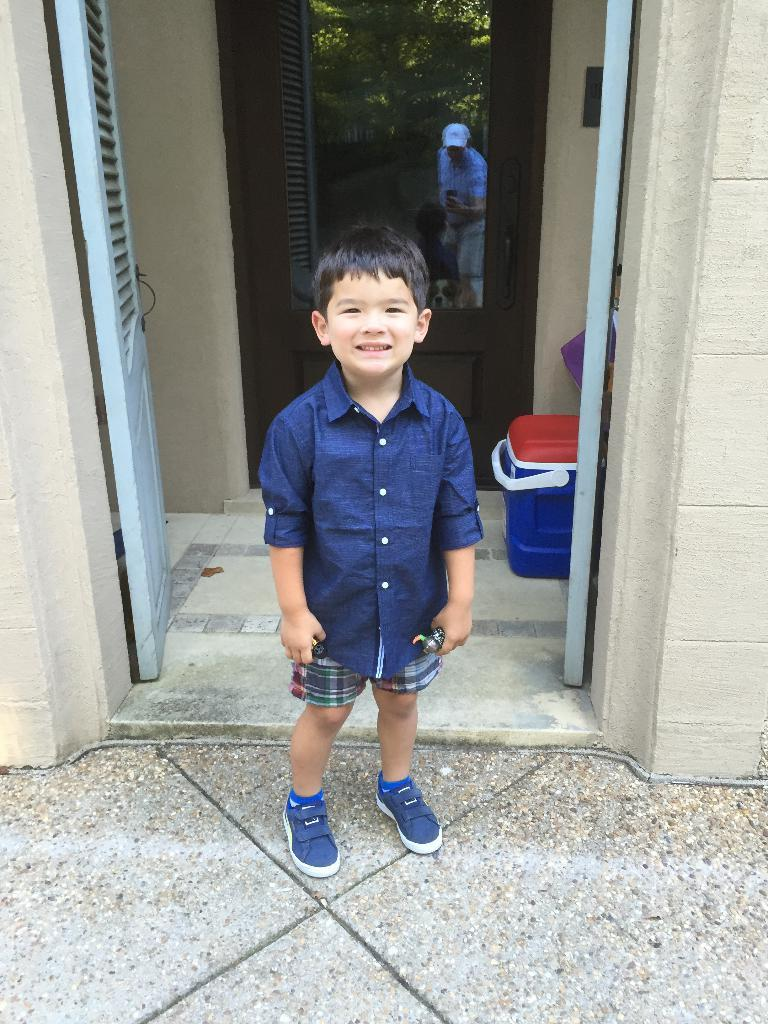What is the kid in the image wearing? The kid is wearing a blue shirt and shorts. Where is the kid located in the image? The kid is standing in front of a door. Can you describe the person behind the door? There appears to be a man standing behind the door. What can be seen on the right side of the image? There is a basket on the right side of the image. What type of pie is the kid holding in the image? There is no pie present in the image; the kid is wearing a blue shirt and shorts and standing in front of a door. 